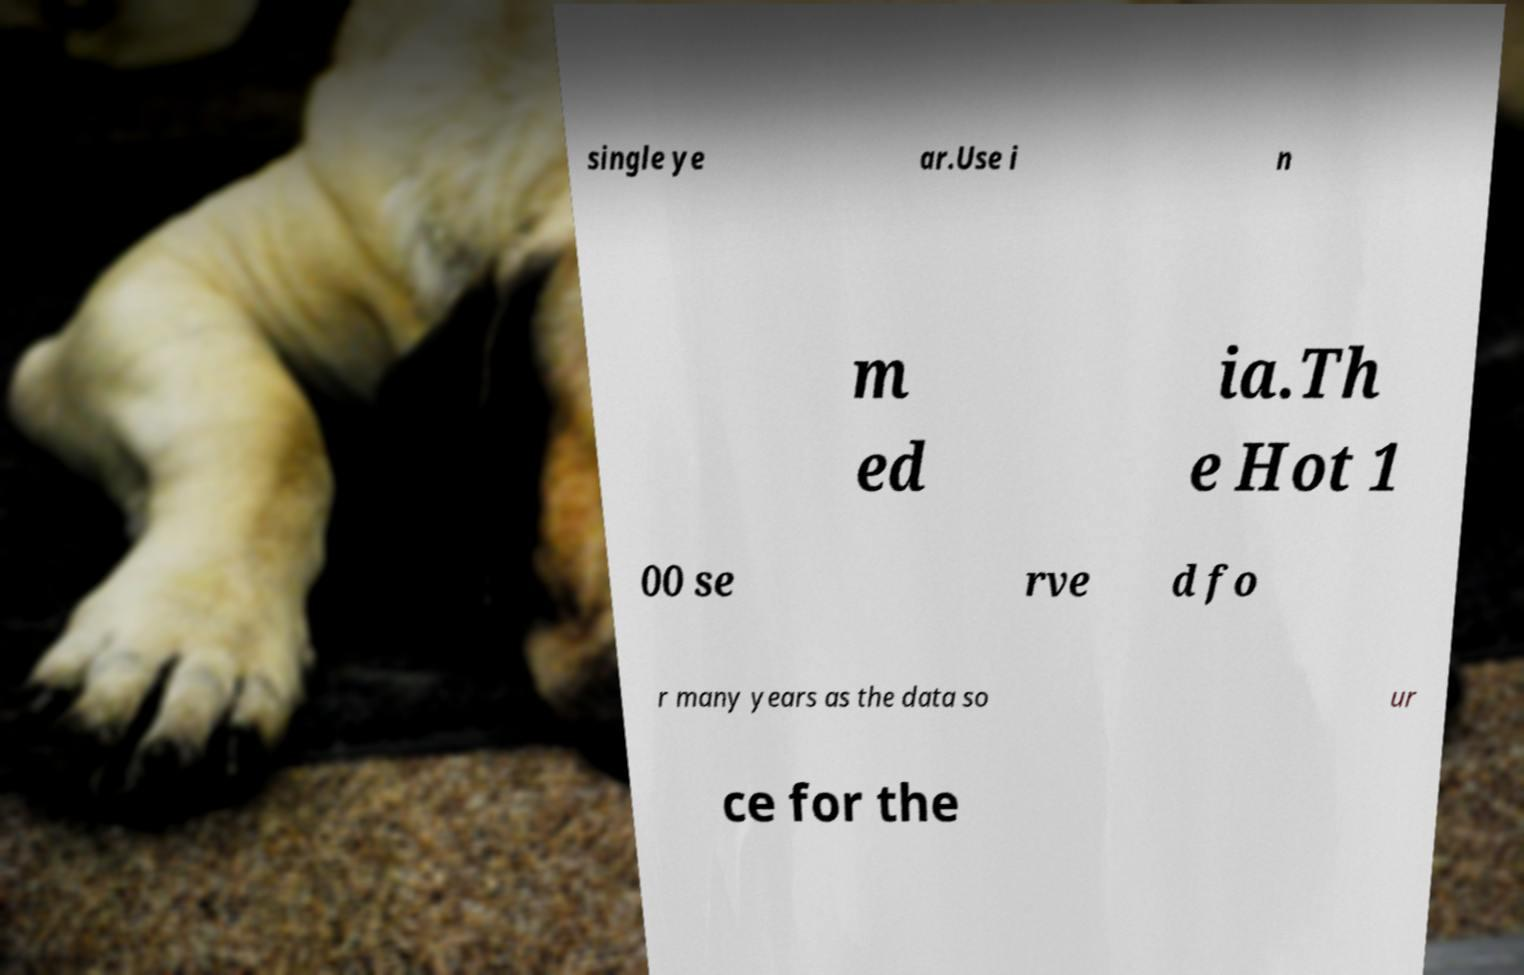Could you assist in decoding the text presented in this image and type it out clearly? single ye ar.Use i n m ed ia.Th e Hot 1 00 se rve d fo r many years as the data so ur ce for the 